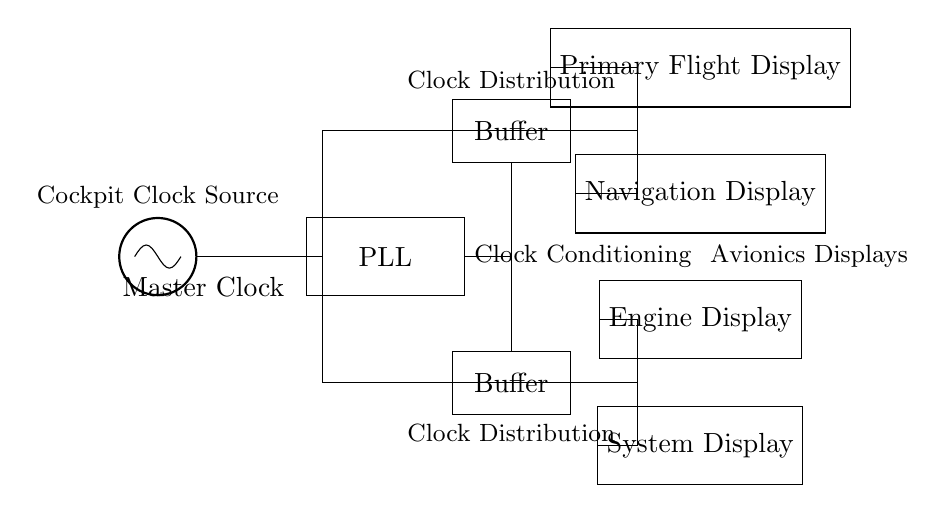What is the main source of the clock signal? The main source of the clock signal in the circuit is labeled as "Master Clock," which is an oscillator that provides the timing signal for the rest of the components.
Answer: Master Clock What is the function of the PLL? The PLL, or Phase-Locked Loop, is used for clock conditioning; it helps to stabilize and clean up the clock signal from the Master Clock before it is distributed to other components.
Answer: Clock Conditioning How many buffers are present in the circuit? The circuit shows two clock buffers that are utilized in the distribution of the clock signal to ensure proper signal strength and integrity to each avionics display.
Answer: Two Which displays are connected to the clock distribution network? The displays connected to the clock distribution network are the Primary Flight Display, Navigation Display, Engine Display, and System Display, which receive their clock signals through the distribution buffers.
Answer: Primary Flight Display, Navigation Display, Engine Display, System Display Explain the role of the clock distribution network. The clock distribution network, consisting of the connections from the PLL to the buffers and subsequently to the displays, ensures that all avionics displays receive a synchronized clock signal. This is crucial for the timely and accurate functioning of the cockpit displays.
Answer: Synchronized clock signal What type of circuit does this diagram represent? The diagram represents a synchronous circuit, where the operation of components such as displays is coordinated by a central clock signal, ensuring that all actions occur at the same time intervals.
Answer: Synchronous Circuit 